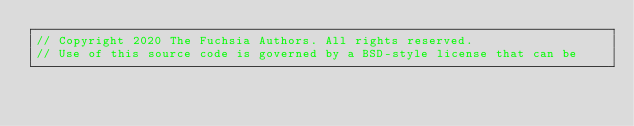<code> <loc_0><loc_0><loc_500><loc_500><_Rust_>// Copyright 2020 The Fuchsia Authors. All rights reserved.
// Use of this source code is governed by a BSD-style license that can be</code> 